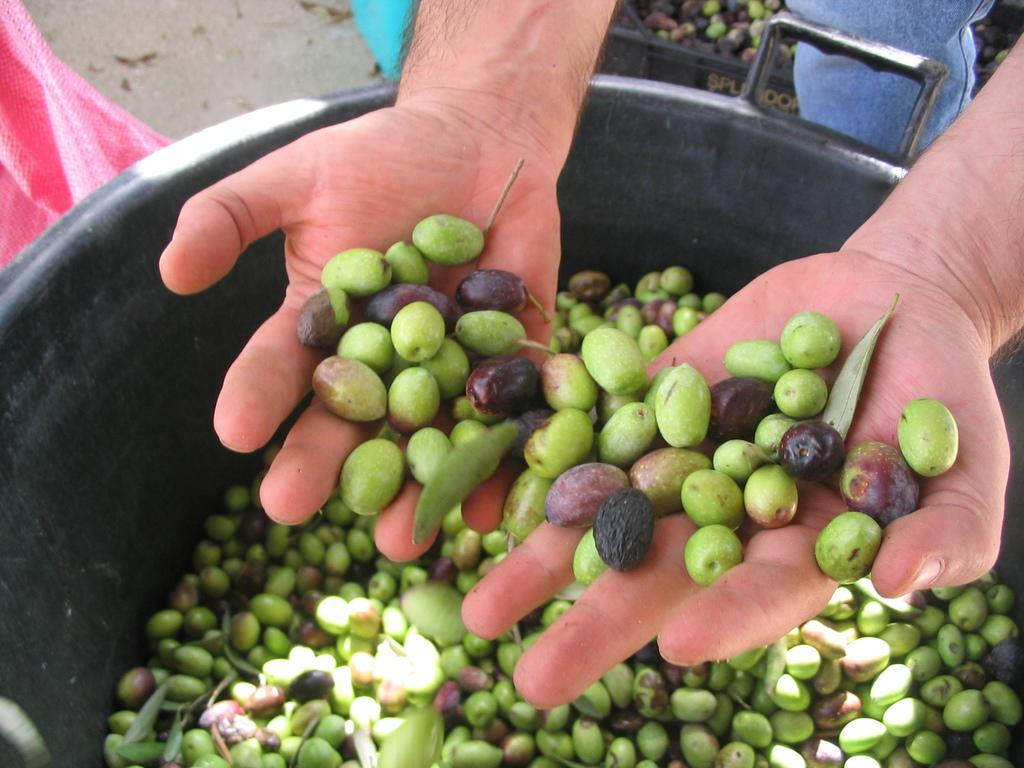What is the person holding in their hand in the image? The person is holding fruits in their hand. What is the relationship between the fruits in the person's hand and the fruits in the bowl? The same type of fruit is present in both the person's hand and the bowl. What type of ink can be seen on the table in the image? There is no ink or table present in the image; it only features a person holding fruits and a bowl of fruits. 